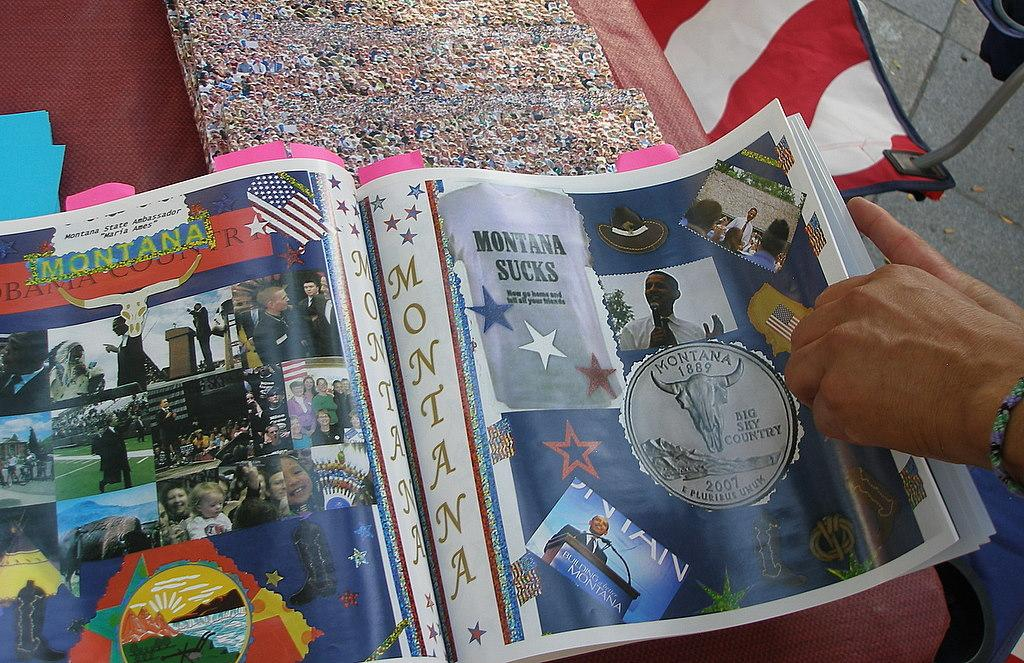<image>
Provide a brief description of the given image. A magazine with an ad for Montana has a picture of Obama with a sign that reads Build a better Montana 